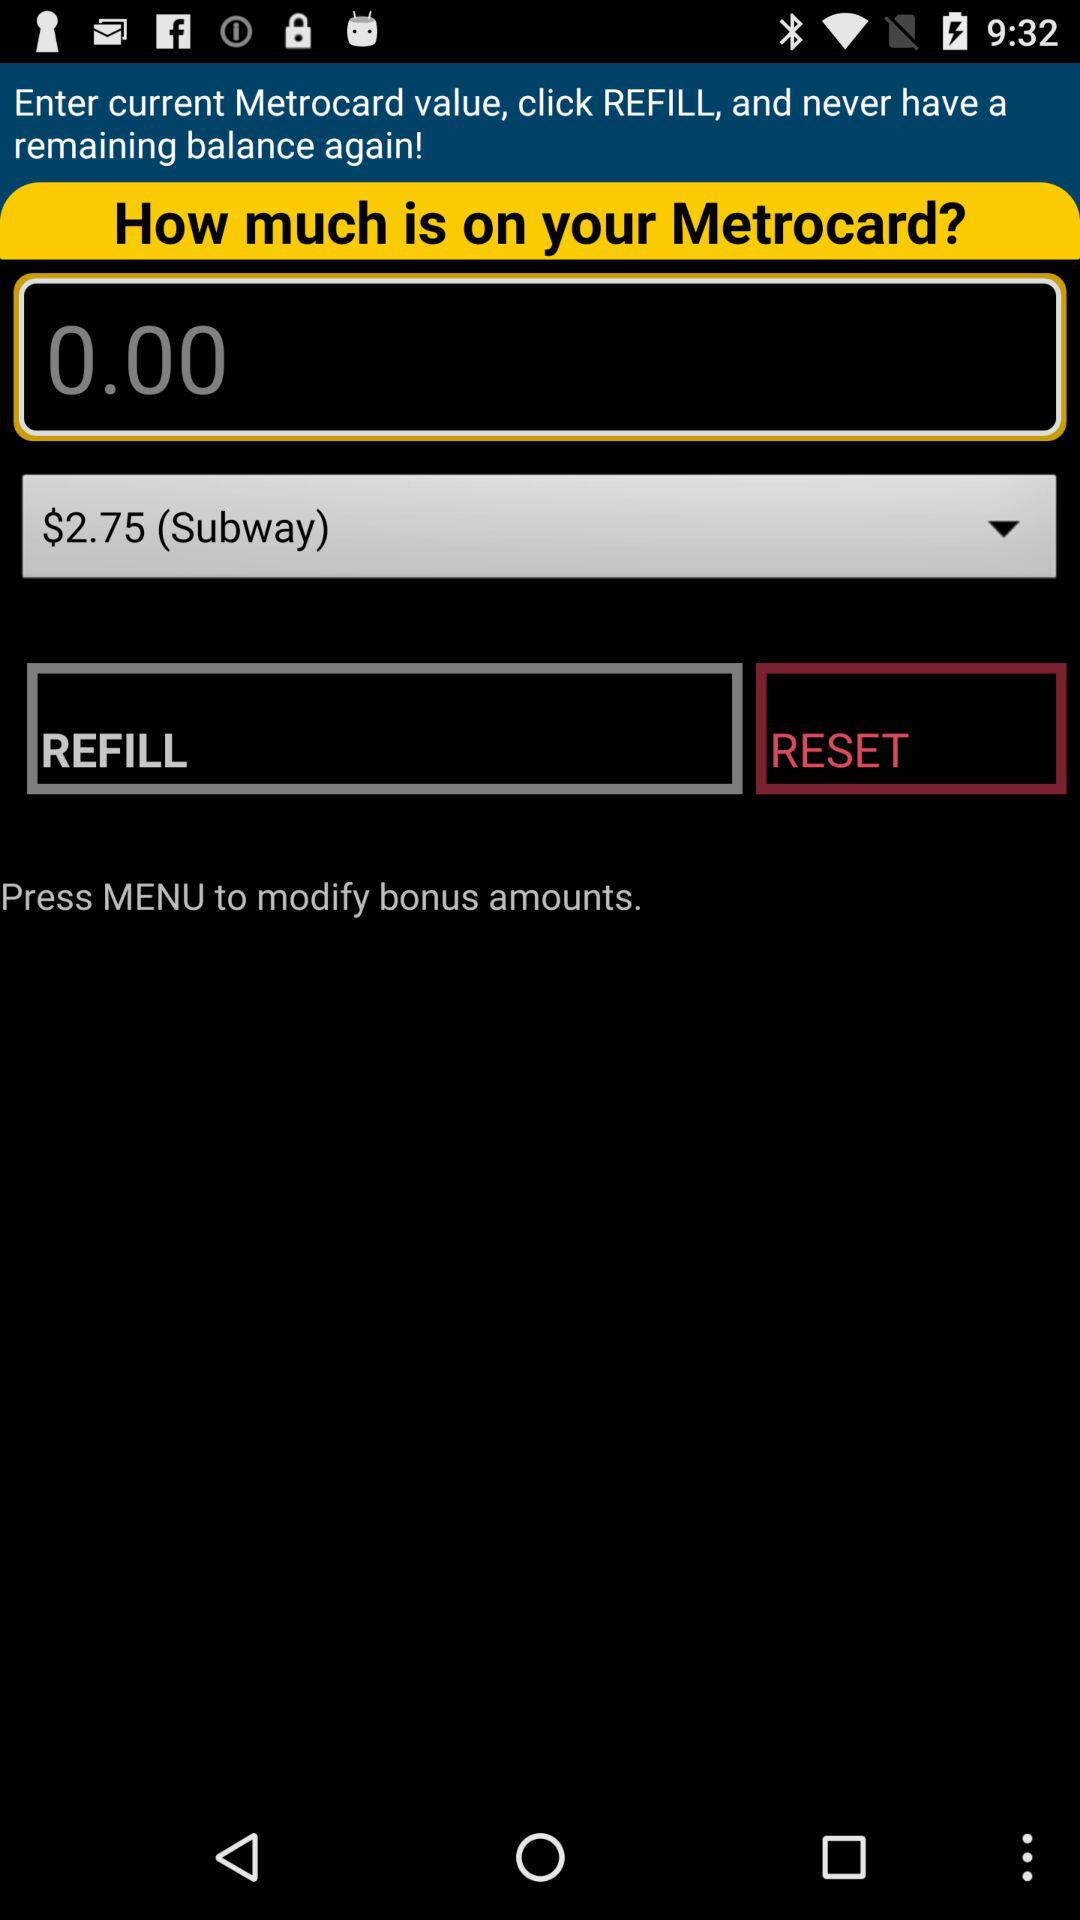Which option should I select to refill?
When the provided information is insufficient, respond with <no answer>. <no answer> 